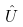Convert formula to latex. <formula><loc_0><loc_0><loc_500><loc_500>\hat { U }</formula> 